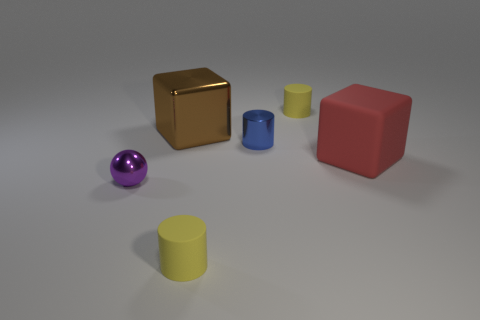Subtract all small matte cylinders. How many cylinders are left? 1 Subtract all blue cylinders. How many cylinders are left? 2 Subtract 1 cubes. How many cubes are left? 1 Add 2 purple shiny spheres. How many objects exist? 8 Subtract 0 brown cylinders. How many objects are left? 6 Subtract all balls. How many objects are left? 5 Subtract all gray cubes. Subtract all green cylinders. How many cubes are left? 2 Subtract all purple spheres. How many brown cylinders are left? 0 Subtract all blue cylinders. Subtract all small yellow rubber things. How many objects are left? 3 Add 5 large metallic objects. How many large metallic objects are left? 6 